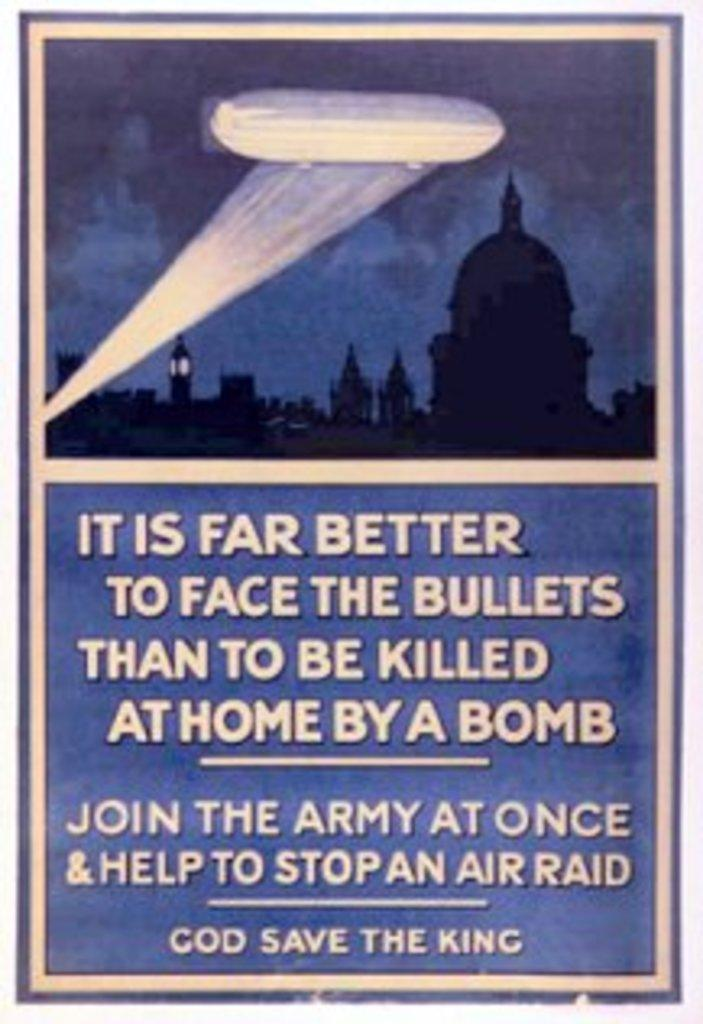<image>
Write a terse but informative summary of the picture. An old poster that says "It is far better to face bullets than to be killed at home by a bomb" 